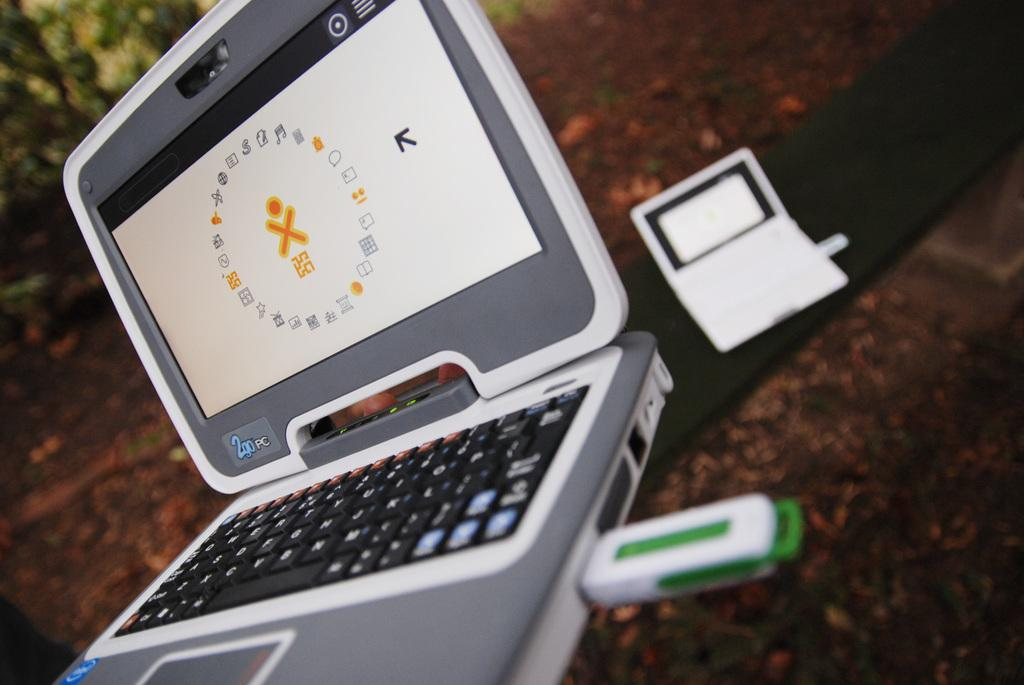<image>
Render a clear and concise summary of the photo. The gray and white laptop is by 2go PC. 